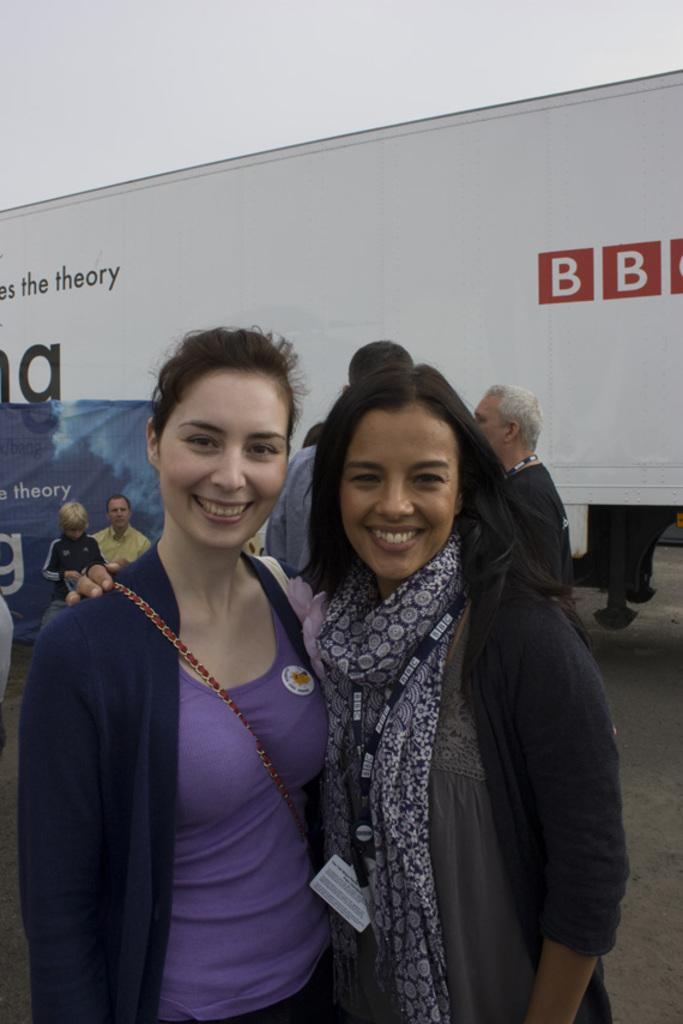How many people are in the image? There is a group of people in the image. What can be observed about the clothing of the people in the image? The people are wearing different color dresses. What is present in the background of the image? There is a banner and a vehicle in the background of the image. What can be seen in the sky in the image? The sky is visible in the background of the image. What type of crib can be seen in the image? There is no crib present in the image. How does the mind of the people in the image appear? The image does not show the minds of the people; it only shows their physical appearance and clothing. 